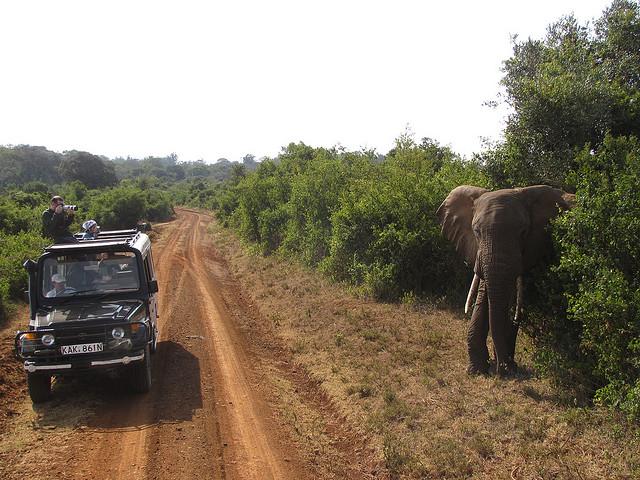How mad is the elephant?
Quick response, please. No. Is this a paved road?
Write a very short answer. No. How many elephants are there?
Quick response, please. 1. 